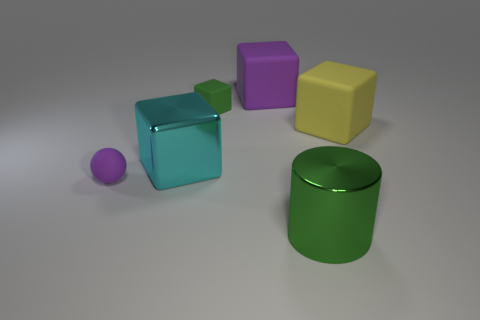Is the number of small things that are on the right side of the small green matte cube the same as the number of tiny green rubber blocks behind the purple block?
Keep it short and to the point. Yes. There is a sphere that is the same material as the large purple block; what color is it?
Provide a short and direct response. Purple. Is there a small purple object that has the same material as the yellow block?
Provide a short and direct response. Yes. What number of objects are large yellow objects or large green shiny cylinders?
Provide a short and direct response. 2. Do the small ball and the purple thing behind the cyan block have the same material?
Provide a short and direct response. Yes. What is the size of the metallic object right of the large purple thing?
Your answer should be compact. Large. Is the number of matte balls less than the number of yellow metal spheres?
Give a very brief answer. No. Is there another cylinder that has the same color as the cylinder?
Your answer should be compact. No. What is the shape of the object that is to the right of the purple cube and in front of the cyan cube?
Your answer should be very brief. Cylinder. What shape is the green object that is on the right side of the purple object behind the small rubber ball?
Your response must be concise. Cylinder. 